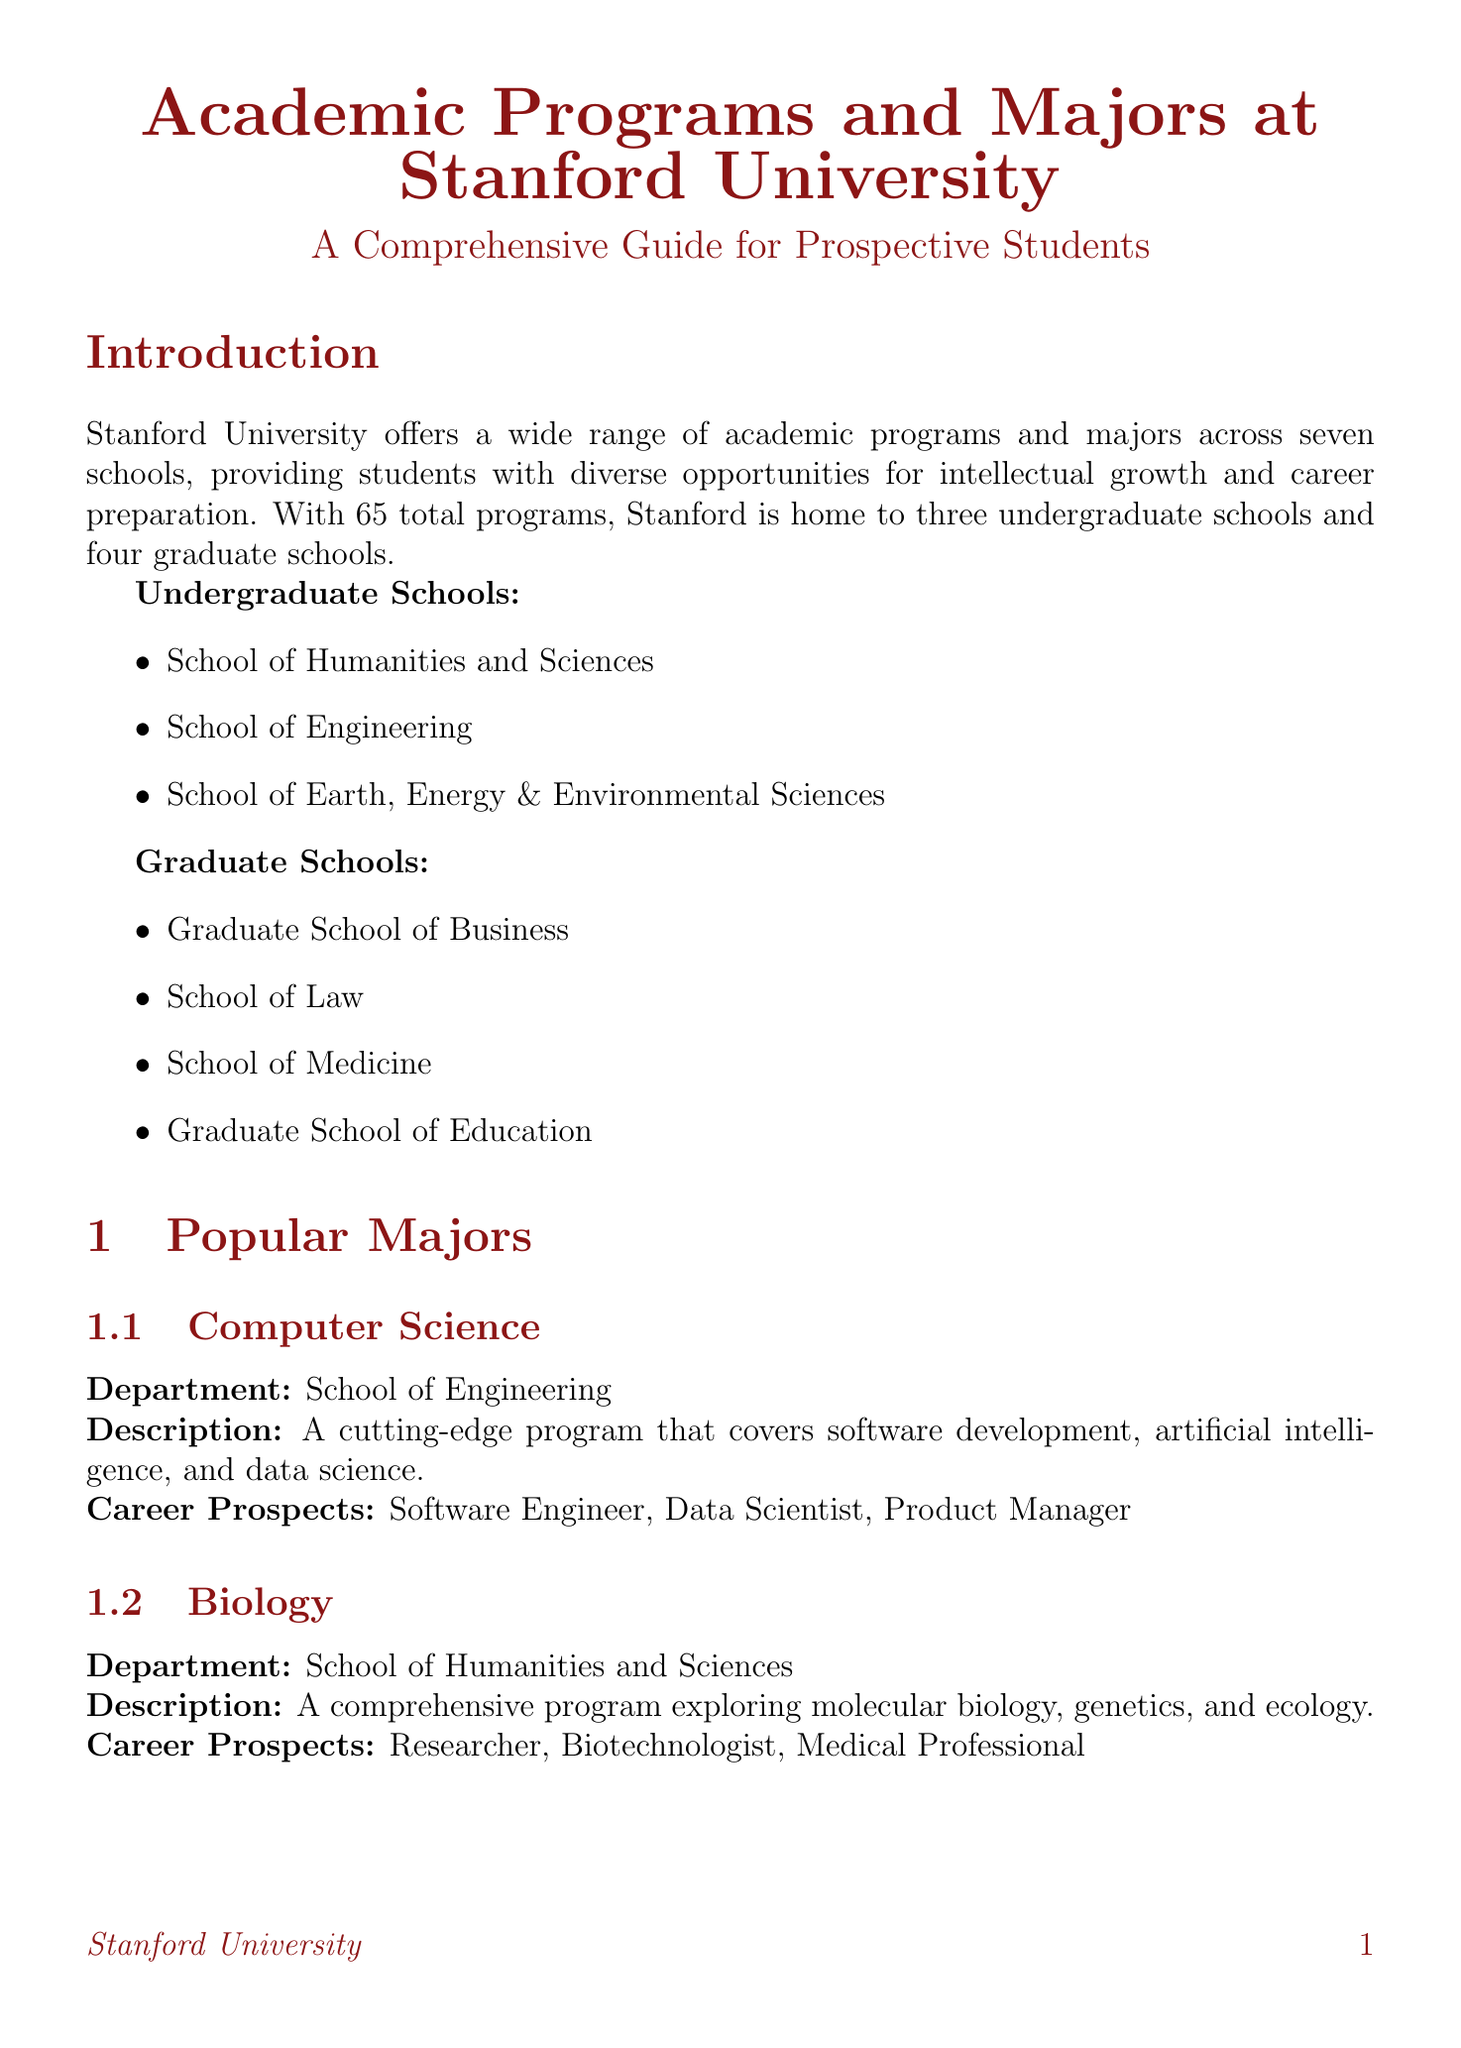What is the total number of academic programs offered at Stanford University? The total number of academic programs is mentioned in the introduction as 65.
Answer: 65 Which program covers molecular biology, genetics, and ecology? The document specifies that Biology is a comprehensive program that explores these areas.
Answer: Biology What is the duration of the Stanford in Florence study abroad program? The document states that the duration of the Stanford in Florence program is one quarter.
Answer: One quarter Who received the Nobel Prize in Economics? The document lists Dr. Alvin Roth as an awardee of the Nobel Prize in Economics.
Answer: Dr. Alvin Roth What interdisciplinary program combines computer science and psychology? The document mentions Symbolic Systems as the interdisciplinary program that combines these fields.
Answer: Symbolic Systems Which service helps students with resume and cover letter reviews? The document notes that BEAM, Stanford Career Education provides this specific service.
Answer: BEAM, Stanford Career Education What is the application deadline for early action? The document lists November 1 as the early action application deadline.
Answer: November 1 Name one popular course offered in the Bing Overseas Studies in Cape Town program. The document provides information about African Politics as one of the popular courses.
Answer: African Politics 